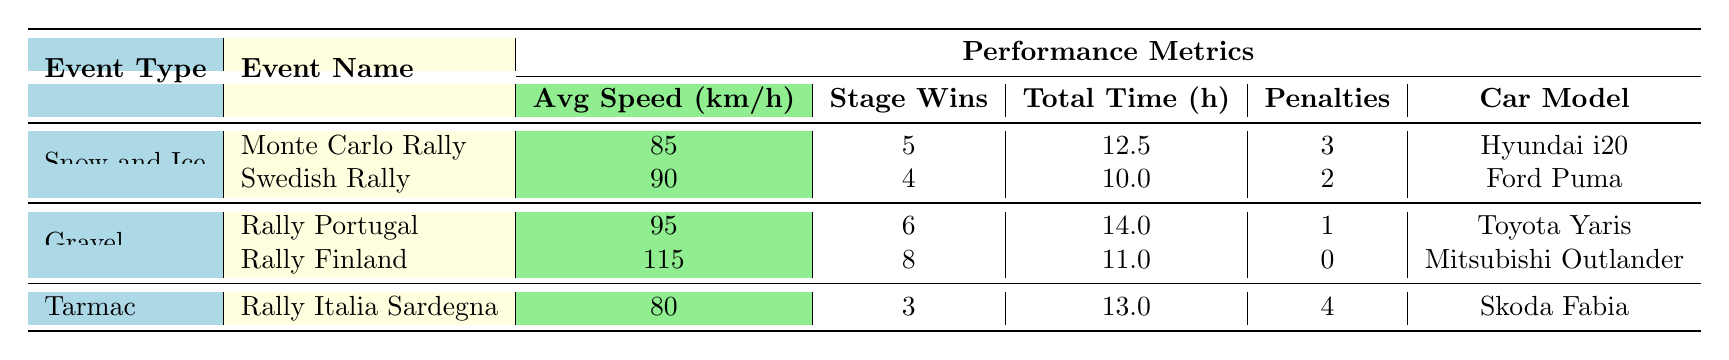What is the average speed in the Monte Carlo Rally? According to the table, the Average Speed for the Monte Carlo Rally is listed as 85 km/h.
Answer: 85 km/h How many stage wins did Rally Finland achieve? The table specifically states that Rally Finland had 8 Stage Wins.
Answer: 8 Which event type has the lowest average speed? By comparing the Average Speed metrics across all event types, Rally Italia Sardegna has the lowest speed at 80 km/h.
Answer: Tarmac What is the total time taken for Rally Portugal? The table indicates that Rally Portugal took a Total Time of 14.0 hours to complete.
Answer: 14.0 hours Did any event receive zero penalties? Upon reviewing the table, Rally Finland is the only event listed with 0 penalties. Hence, the answer is yes.
Answer: Yes Which car model had the highest average speed? Comparing the average speeds, Mitsubishi Outlander used in Rally Finland has the highest speed at 115 km/h.
Answer: Mitsubishi Outlander What is the difference in average speed between the fastest and slowest events? The fastest average speed is from Rally Finland at 115 km/h, and the slowest is from Rally Italia Sardegna at 80 km/h. The difference is 115 - 80 = 35 km/h.
Answer: 35 km/h How many stage wins were achieved in all Snow and Ice events combined? For the Snow and Ice events (Monte Carlo Rally - 5 Stage Wins and Swedish Rally - 4 Stage Wins), the total is 5 + 4 = 9 Stage Wins.
Answer: 9 Is there an event with more than 3 penalties? The table indicates that the Rally Italia Sardegna has 4 penalties, so the answer is yes.
Answer: Yes 